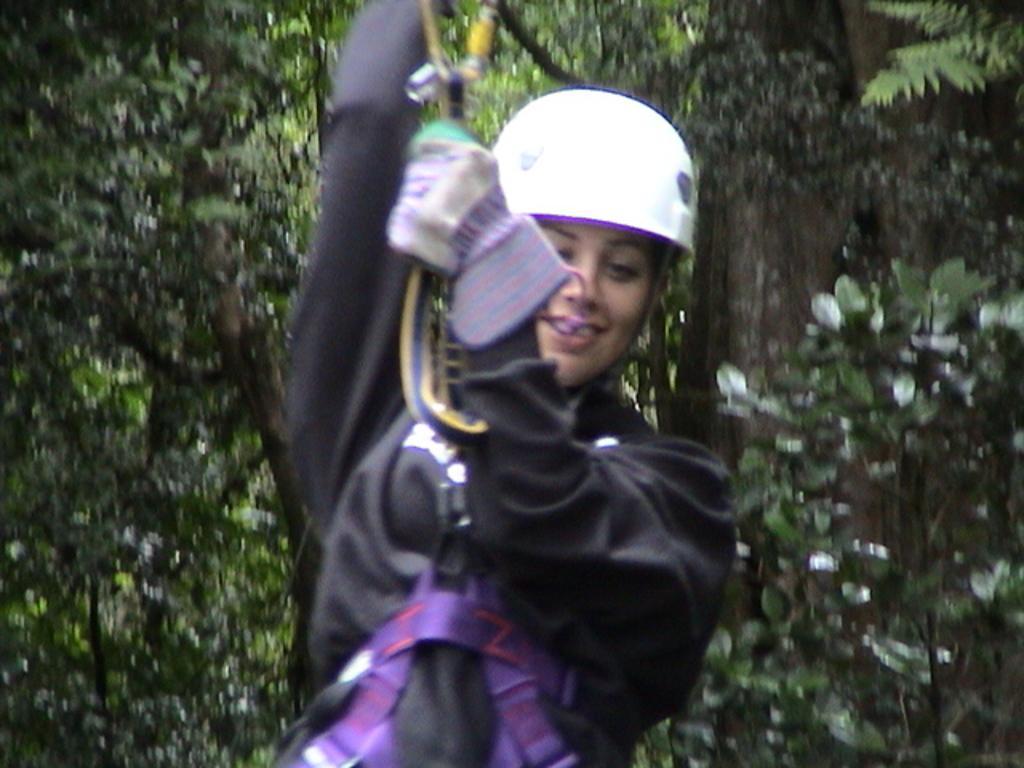Can you describe this image briefly? This is the woman holding the rope and hanging. She wore a helmet and a jerkin. These are the trees with branches and leaves. 